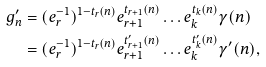<formula> <loc_0><loc_0><loc_500><loc_500>g _ { n } ^ { \prime } & = ( e _ { r } ^ { - 1 } ) ^ { 1 - t _ { r } ( n ) } e _ { r + 1 } ^ { t _ { r + 1 } ( n ) } \dots e _ { k } ^ { t _ { k } ( n ) } \gamma ( n ) \\ & = ( e _ { r } ^ { - 1 } ) ^ { 1 - t _ { r } ( n ) } e _ { r + 1 } ^ { t _ { r + 1 } ^ { \prime } ( n ) } \dots e _ { k } ^ { t ^ { \prime } _ { k } ( n ) } \gamma ^ { \prime } ( n ) ,</formula> 